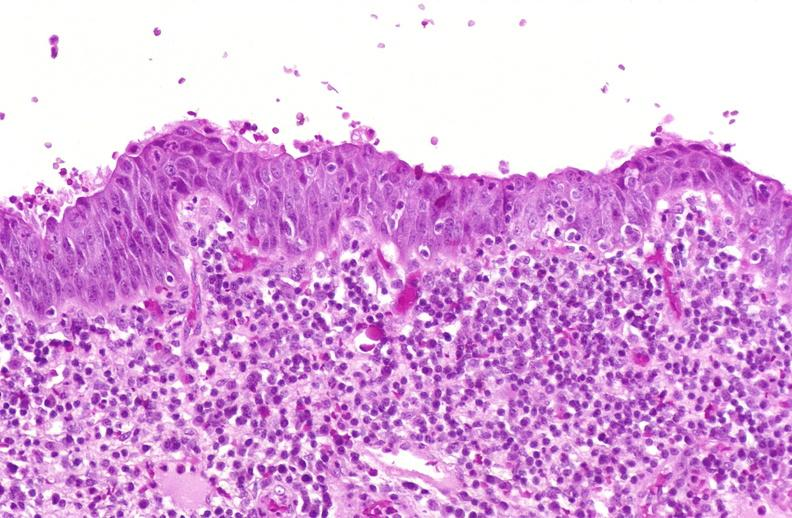does bone, skull show squamous metaplasia, renal pelvis due to nephrolithiasis?
Answer the question using a single word or phrase. No 